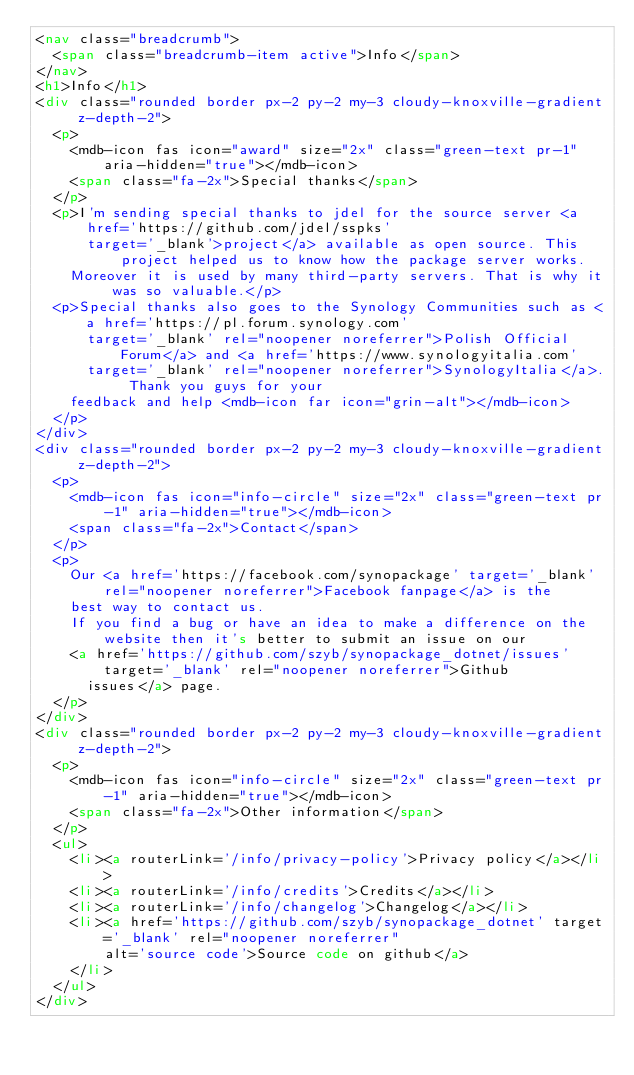Convert code to text. <code><loc_0><loc_0><loc_500><loc_500><_HTML_><nav class="breadcrumb">
  <span class="breadcrumb-item active">Info</span>
</nav>
<h1>Info</h1>
<div class="rounded border px-2 py-2 my-3 cloudy-knoxville-gradient z-depth-2">
  <p>
    <mdb-icon fas icon="award" size="2x" class="green-text pr-1" aria-hidden="true"></mdb-icon>
    <span class="fa-2x">Special thanks</span>
  </p>
  <p>I'm sending special thanks to jdel for the source server <a href='https://github.com/jdel/sspks'
      target='_blank'>project</a> available as open source. This project helped us to know how the package server works.
    Moreover it is used by many third-party servers. That is why it was so valuable.</p>
  <p>Special thanks also goes to the Synology Communities such as <a href='https://pl.forum.synology.com'
      target='_blank' rel="noopener noreferrer">Polish Official Forum</a> and <a href='https://www.synologyitalia.com'
      target='_blank' rel="noopener noreferrer">SynologyItalia</a>. Thank you guys for your
    feedback and help <mdb-icon far icon="grin-alt"></mdb-icon>
  </p>
</div>
<div class="rounded border px-2 py-2 my-3 cloudy-knoxville-gradient z-depth-2">
  <p>
    <mdb-icon fas icon="info-circle" size="2x" class="green-text pr-1" aria-hidden="true"></mdb-icon>
    <span class="fa-2x">Contact</span>
  </p>
  <p>
    Our <a href='https://facebook.com/synopackage' target='_blank' rel="noopener noreferrer">Facebook fanpage</a> is the
    best way to contact us.
    If you find a bug or have an idea to make a difference on the website then it's better to submit an issue on our
    <a href='https://github.com/szyb/synopackage_dotnet/issues' target='_blank' rel="noopener noreferrer">Github
      issues</a> page.
  </p>
</div>
<div class="rounded border px-2 py-2 my-3 cloudy-knoxville-gradient z-depth-2">
  <p>
    <mdb-icon fas icon="info-circle" size="2x" class="green-text pr-1" aria-hidden="true"></mdb-icon>
    <span class="fa-2x">Other information</span>
  </p>
  <ul>
    <li><a routerLink='/info/privacy-policy'>Privacy policy</a></li>
    <li><a routerLink='/info/credits'>Credits</a></li>
    <li><a routerLink='/info/changelog'>Changelog</a></li>
    <li><a href='https://github.com/szyb/synopackage_dotnet' target='_blank' rel="noopener noreferrer"
        alt='source code'>Source code on github</a>
    </li>
  </ul>
</div>
</code> 